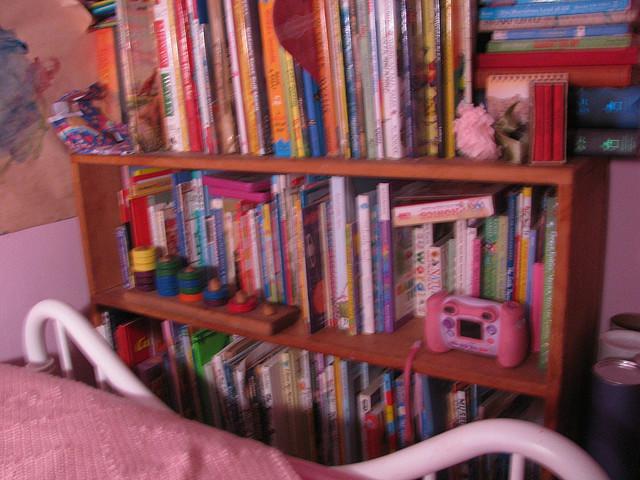Are the books likely to be novels?
Answer briefly. No. What else is on the bookshelf?
Concise answer only. Toys. Does someone read a lot?
Answer briefly. Yes. 